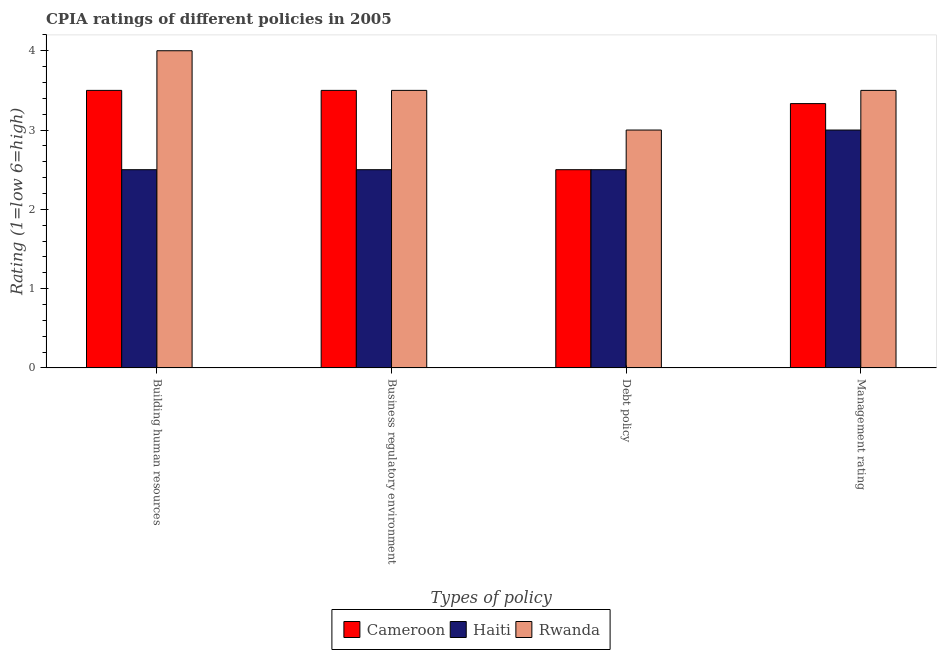Are the number of bars on each tick of the X-axis equal?
Keep it short and to the point. Yes. What is the label of the 3rd group of bars from the left?
Provide a succinct answer. Debt policy. In which country was the cpia rating of management maximum?
Your response must be concise. Rwanda. In which country was the cpia rating of debt policy minimum?
Provide a succinct answer. Cameroon. What is the total cpia rating of management in the graph?
Ensure brevity in your answer.  9.83. What is the difference between the cpia rating of business regulatory environment in Cameroon and that in Rwanda?
Give a very brief answer. 0. What is the average cpia rating of business regulatory environment per country?
Make the answer very short. 3.17. What is the difference between the cpia rating of business regulatory environment and cpia rating of building human resources in Haiti?
Offer a very short reply. 0. What is the ratio of the cpia rating of building human resources in Haiti to that in Cameroon?
Make the answer very short. 0.71. Is it the case that in every country, the sum of the cpia rating of business regulatory environment and cpia rating of debt policy is greater than the sum of cpia rating of management and cpia rating of building human resources?
Offer a very short reply. No. What does the 1st bar from the left in Debt policy represents?
Give a very brief answer. Cameroon. What does the 1st bar from the right in Management rating represents?
Provide a succinct answer. Rwanda. Is it the case that in every country, the sum of the cpia rating of building human resources and cpia rating of business regulatory environment is greater than the cpia rating of debt policy?
Keep it short and to the point. Yes. How many bars are there?
Provide a succinct answer. 12. Does the graph contain any zero values?
Ensure brevity in your answer.  No. Where does the legend appear in the graph?
Your response must be concise. Bottom center. How many legend labels are there?
Provide a short and direct response. 3. How are the legend labels stacked?
Provide a short and direct response. Horizontal. What is the title of the graph?
Keep it short and to the point. CPIA ratings of different policies in 2005. What is the label or title of the X-axis?
Ensure brevity in your answer.  Types of policy. What is the label or title of the Y-axis?
Provide a short and direct response. Rating (1=low 6=high). What is the Rating (1=low 6=high) of Cameroon in Building human resources?
Ensure brevity in your answer.  3.5. What is the Rating (1=low 6=high) in Haiti in Building human resources?
Offer a very short reply. 2.5. What is the Rating (1=low 6=high) in Cameroon in Business regulatory environment?
Your answer should be compact. 3.5. What is the Rating (1=low 6=high) in Cameroon in Debt policy?
Keep it short and to the point. 2.5. What is the Rating (1=low 6=high) of Haiti in Debt policy?
Your answer should be compact. 2.5. What is the Rating (1=low 6=high) of Rwanda in Debt policy?
Ensure brevity in your answer.  3. What is the Rating (1=low 6=high) of Cameroon in Management rating?
Offer a very short reply. 3.33. What is the Rating (1=low 6=high) of Haiti in Management rating?
Keep it short and to the point. 3. Across all Types of policy, what is the maximum Rating (1=low 6=high) of Cameroon?
Offer a very short reply. 3.5. Across all Types of policy, what is the maximum Rating (1=low 6=high) in Haiti?
Provide a succinct answer. 3. Across all Types of policy, what is the maximum Rating (1=low 6=high) in Rwanda?
Keep it short and to the point. 4. What is the total Rating (1=low 6=high) in Cameroon in the graph?
Your response must be concise. 12.83. What is the total Rating (1=low 6=high) of Haiti in the graph?
Give a very brief answer. 10.5. What is the difference between the Rating (1=low 6=high) in Cameroon in Building human resources and that in Business regulatory environment?
Give a very brief answer. 0. What is the difference between the Rating (1=low 6=high) in Rwanda in Building human resources and that in Business regulatory environment?
Offer a terse response. 0.5. What is the difference between the Rating (1=low 6=high) of Cameroon in Building human resources and that in Debt policy?
Provide a succinct answer. 1. What is the difference between the Rating (1=low 6=high) in Haiti in Building human resources and that in Debt policy?
Your response must be concise. 0. What is the difference between the Rating (1=low 6=high) in Rwanda in Building human resources and that in Debt policy?
Your answer should be compact. 1. What is the difference between the Rating (1=low 6=high) of Haiti in Building human resources and that in Management rating?
Keep it short and to the point. -0.5. What is the difference between the Rating (1=low 6=high) of Cameroon in Business regulatory environment and that in Debt policy?
Give a very brief answer. 1. What is the difference between the Rating (1=low 6=high) in Haiti in Business regulatory environment and that in Debt policy?
Offer a terse response. 0. What is the difference between the Rating (1=low 6=high) of Rwanda in Business regulatory environment and that in Debt policy?
Make the answer very short. 0.5. What is the difference between the Rating (1=low 6=high) in Cameroon in Business regulatory environment and that in Management rating?
Give a very brief answer. 0.17. What is the difference between the Rating (1=low 6=high) in Rwanda in Business regulatory environment and that in Management rating?
Offer a terse response. 0. What is the difference between the Rating (1=low 6=high) in Rwanda in Debt policy and that in Management rating?
Provide a succinct answer. -0.5. What is the difference between the Rating (1=low 6=high) in Cameroon in Building human resources and the Rating (1=low 6=high) in Haiti in Business regulatory environment?
Make the answer very short. 1. What is the difference between the Rating (1=low 6=high) in Cameroon in Building human resources and the Rating (1=low 6=high) in Rwanda in Business regulatory environment?
Provide a short and direct response. 0. What is the difference between the Rating (1=low 6=high) in Cameroon in Building human resources and the Rating (1=low 6=high) in Haiti in Debt policy?
Ensure brevity in your answer.  1. What is the difference between the Rating (1=low 6=high) of Cameroon in Building human resources and the Rating (1=low 6=high) of Haiti in Management rating?
Provide a short and direct response. 0.5. What is the difference between the Rating (1=low 6=high) in Haiti in Business regulatory environment and the Rating (1=low 6=high) in Rwanda in Debt policy?
Offer a very short reply. -0.5. What is the difference between the Rating (1=low 6=high) in Cameroon in Business regulatory environment and the Rating (1=low 6=high) in Haiti in Management rating?
Your answer should be compact. 0.5. What is the difference between the Rating (1=low 6=high) in Cameroon in Business regulatory environment and the Rating (1=low 6=high) in Rwanda in Management rating?
Your answer should be compact. 0. What is the difference between the Rating (1=low 6=high) of Cameroon in Debt policy and the Rating (1=low 6=high) of Rwanda in Management rating?
Give a very brief answer. -1. What is the average Rating (1=low 6=high) of Cameroon per Types of policy?
Provide a short and direct response. 3.21. What is the average Rating (1=low 6=high) of Haiti per Types of policy?
Offer a terse response. 2.62. What is the difference between the Rating (1=low 6=high) of Cameroon and Rating (1=low 6=high) of Rwanda in Building human resources?
Give a very brief answer. -0.5. What is the difference between the Rating (1=low 6=high) in Haiti and Rating (1=low 6=high) in Rwanda in Building human resources?
Your answer should be compact. -1.5. What is the difference between the Rating (1=low 6=high) in Cameroon and Rating (1=low 6=high) in Haiti in Business regulatory environment?
Make the answer very short. 1. What is the difference between the Rating (1=low 6=high) in Cameroon and Rating (1=low 6=high) in Rwanda in Business regulatory environment?
Offer a very short reply. 0. What is the difference between the Rating (1=low 6=high) in Cameroon and Rating (1=low 6=high) in Haiti in Debt policy?
Offer a very short reply. 0. What is the difference between the Rating (1=low 6=high) of Haiti and Rating (1=low 6=high) of Rwanda in Management rating?
Make the answer very short. -0.5. What is the ratio of the Rating (1=low 6=high) of Rwanda in Building human resources to that in Business regulatory environment?
Offer a terse response. 1.14. What is the ratio of the Rating (1=low 6=high) in Cameroon in Building human resources to that in Debt policy?
Provide a short and direct response. 1.4. What is the ratio of the Rating (1=low 6=high) of Haiti in Building human resources to that in Debt policy?
Ensure brevity in your answer.  1. What is the ratio of the Rating (1=low 6=high) in Rwanda in Building human resources to that in Debt policy?
Keep it short and to the point. 1.33. What is the ratio of the Rating (1=low 6=high) in Rwanda in Building human resources to that in Management rating?
Give a very brief answer. 1.14. What is the ratio of the Rating (1=low 6=high) of Cameroon in Business regulatory environment to that in Debt policy?
Ensure brevity in your answer.  1.4. What is the ratio of the Rating (1=low 6=high) of Haiti in Business regulatory environment to that in Debt policy?
Offer a terse response. 1. What is the ratio of the Rating (1=low 6=high) in Rwanda in Business regulatory environment to that in Debt policy?
Give a very brief answer. 1.17. What is the ratio of the Rating (1=low 6=high) in Cameroon in Business regulatory environment to that in Management rating?
Offer a very short reply. 1.05. What is the ratio of the Rating (1=low 6=high) in Haiti in Business regulatory environment to that in Management rating?
Provide a succinct answer. 0.83. What is the ratio of the Rating (1=low 6=high) in Cameroon in Debt policy to that in Management rating?
Make the answer very short. 0.75. What is the ratio of the Rating (1=low 6=high) in Haiti in Debt policy to that in Management rating?
Offer a very short reply. 0.83. What is the difference between the highest and the lowest Rating (1=low 6=high) of Cameroon?
Make the answer very short. 1. What is the difference between the highest and the lowest Rating (1=low 6=high) of Rwanda?
Offer a very short reply. 1. 